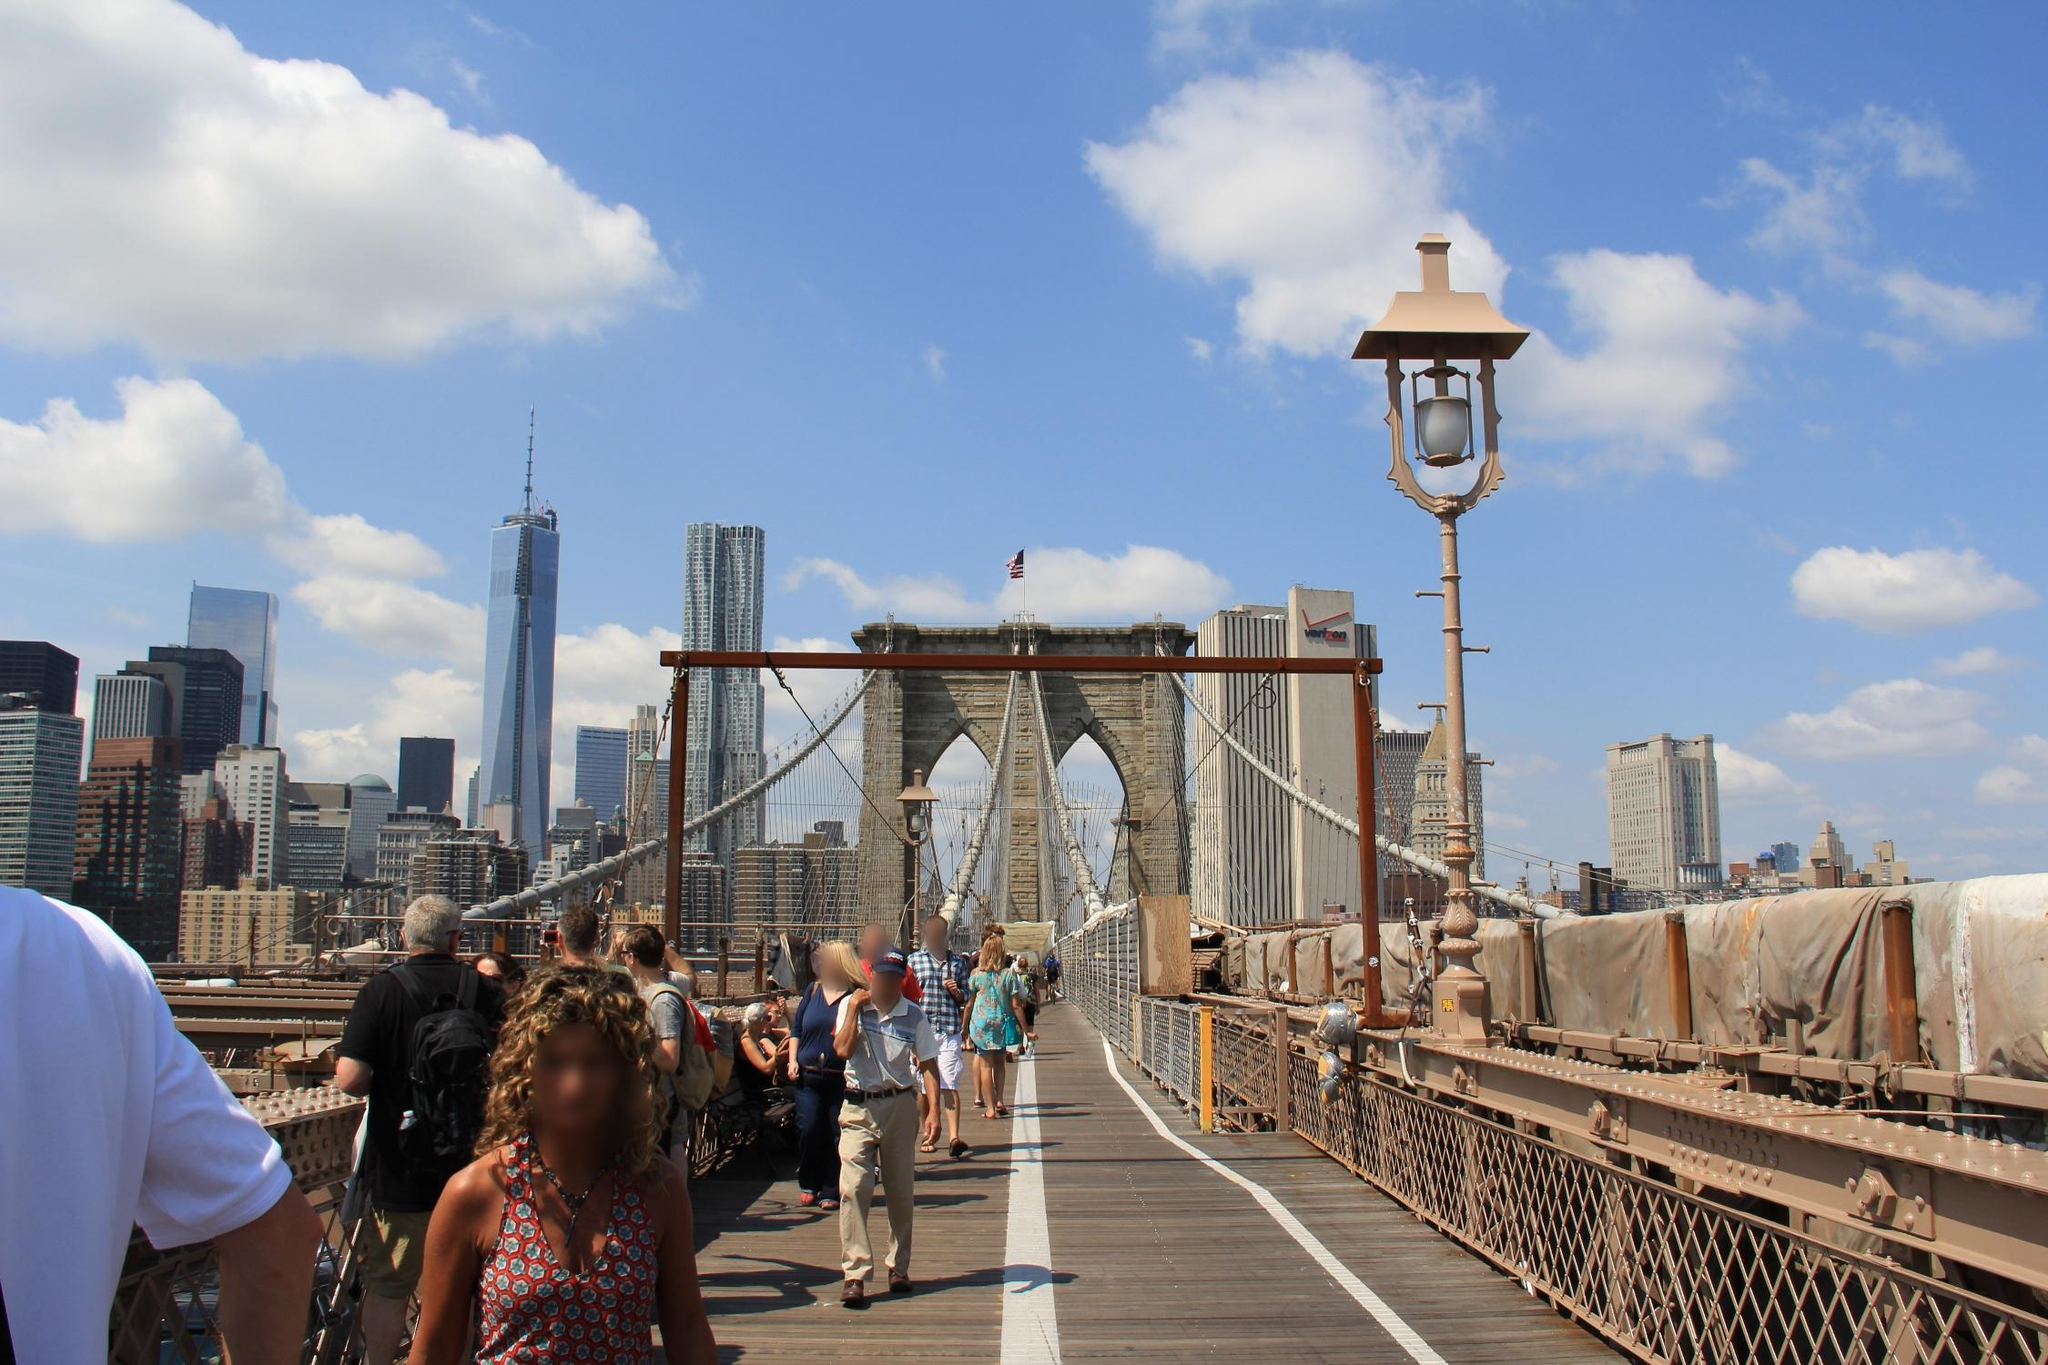Describe what activities people on the bridge might be engaging in. From the image, it is evident that the pedestrian walkway on the Brooklyn Bridge is bustling with activity. People appear to be enjoying a leisurely walk, some perhaps taking in the architectural beauty of the bridge and the scenic views of the Manhattan skyline. Many might be tourists, as indicated by their casual attire and cameras, capturing memories of their visit. There might also be joggers or bicyclists using the bridge for exercise. The atmosphere suggests a blend of both routine and recreational use, embodying the bridge's role as a lively urban thoroughfare. 